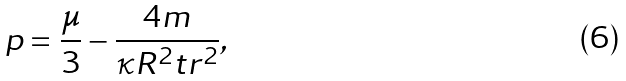Convert formula to latex. <formula><loc_0><loc_0><loc_500><loc_500>p = \frac { \mu } { 3 } - \frac { 4 m } { \kappa R ^ { 2 } t r ^ { 2 } } ,</formula> 